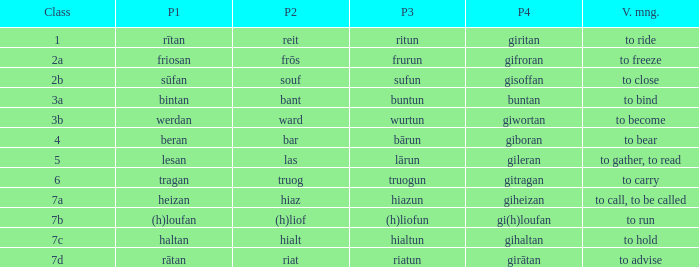What is the part 4 when part 1 is "lesan"? Gileran. 